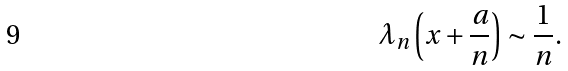Convert formula to latex. <formula><loc_0><loc_0><loc_500><loc_500>\lambda _ { n } \left ( x + \frac { a } { n } \right ) \sim \frac { 1 } { n } .</formula> 